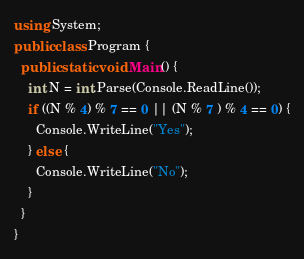Convert code to text. <code><loc_0><loc_0><loc_500><loc_500><_C#_>using System;
public class Program {
  public static void Main() {
    int N = int.Parse(Console.ReadLine());
    if ((N % 4) % 7 == 0 || (N % 7 ) % 4 == 0) {
      Console.WriteLine("Yes");
    } else {
      Console.WriteLine("No");
    }
  }
}
</code> 